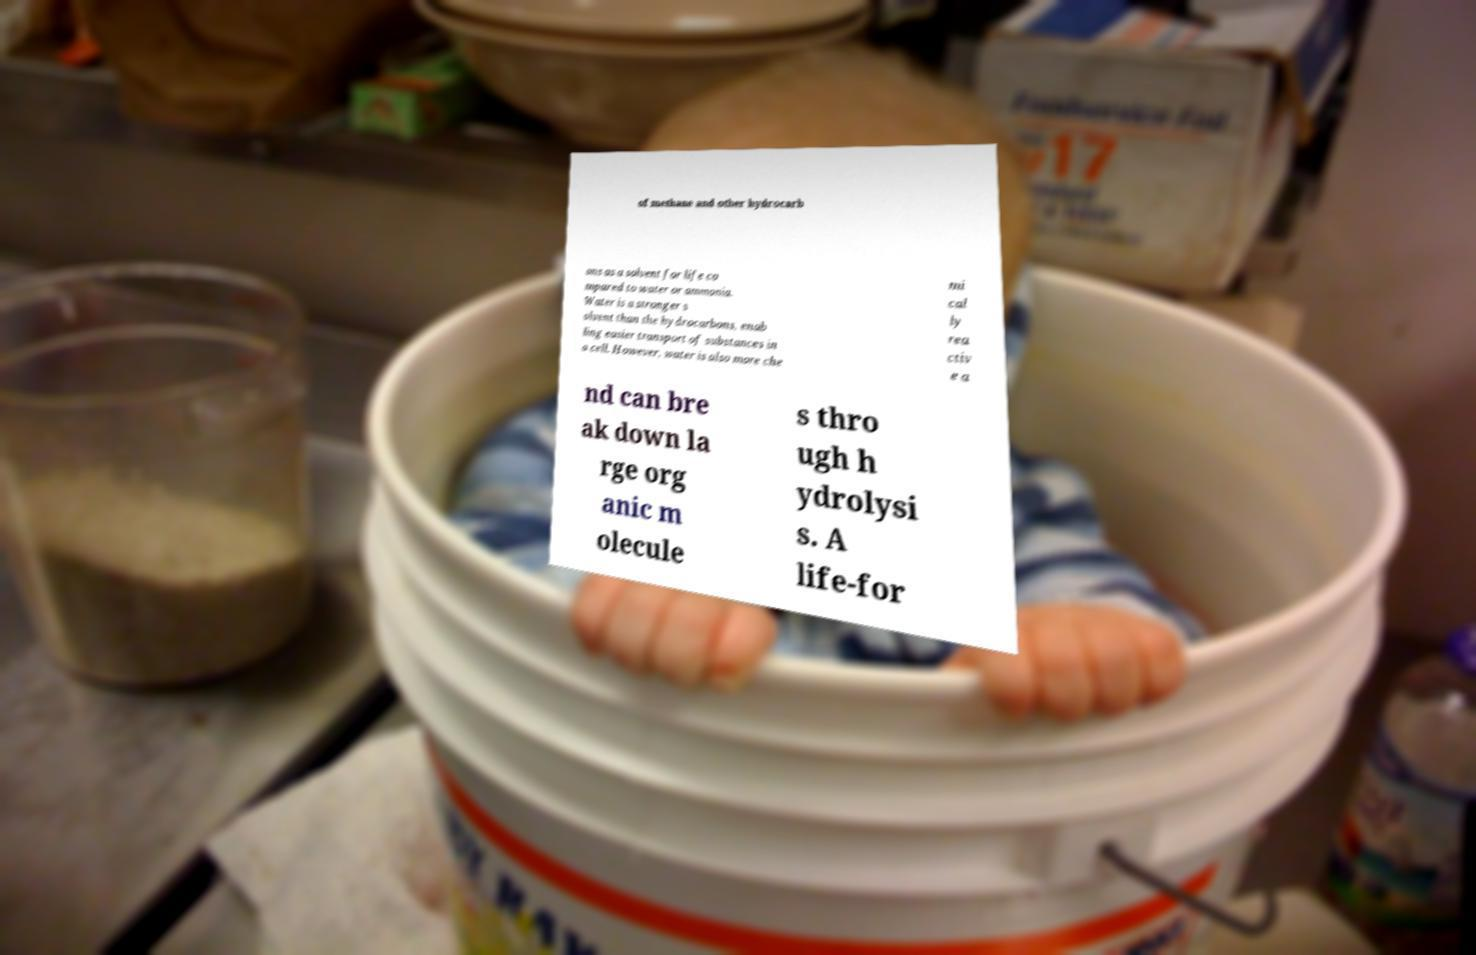For documentation purposes, I need the text within this image transcribed. Could you provide that? of methane and other hydrocarb ons as a solvent for life co mpared to water or ammonia. Water is a stronger s olvent than the hydrocarbons, enab ling easier transport of substances in a cell. However, water is also more che mi cal ly rea ctiv e a nd can bre ak down la rge org anic m olecule s thro ugh h ydrolysi s. A life-for 